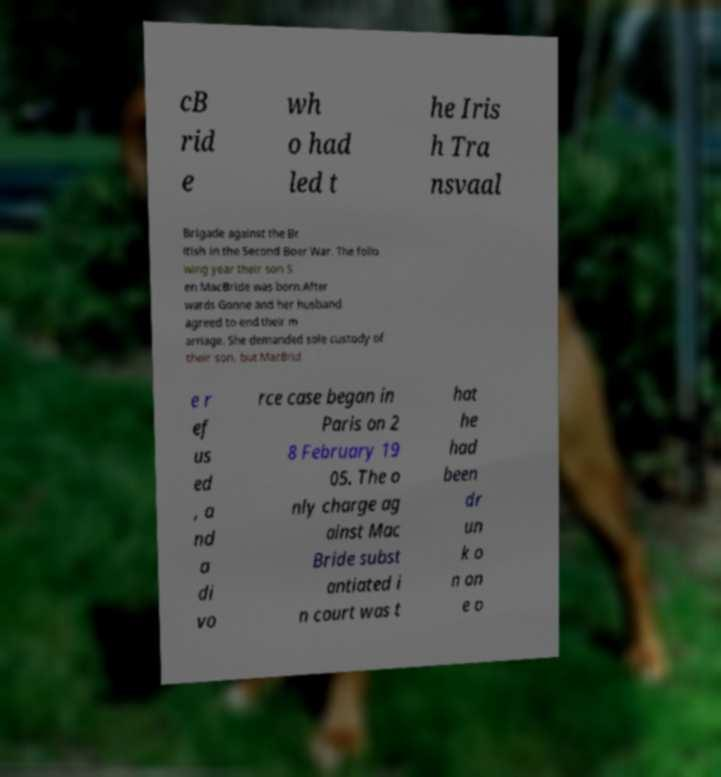Please identify and transcribe the text found in this image. cB rid e wh o had led t he Iris h Tra nsvaal Brigade against the Br itish in the Second Boer War. The follo wing year their son S en MacBride was born.After wards Gonne and her husband agreed to end their m arriage. She demanded sole custody of their son, but MacBrid e r ef us ed , a nd a di vo rce case began in Paris on 2 8 February 19 05. The o nly charge ag ainst Mac Bride subst antiated i n court was t hat he had been dr un k o n on e o 